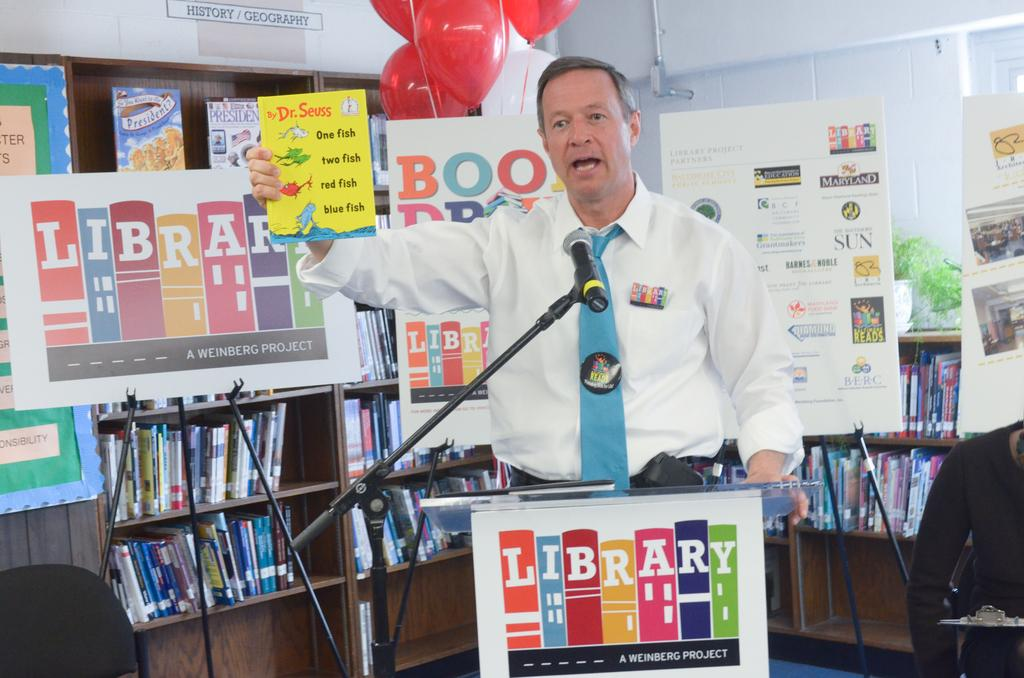<image>
Relay a brief, clear account of the picture shown. A man stands behind a library podium and holds up a Dr. Seuss book about tallying fish quantities. 